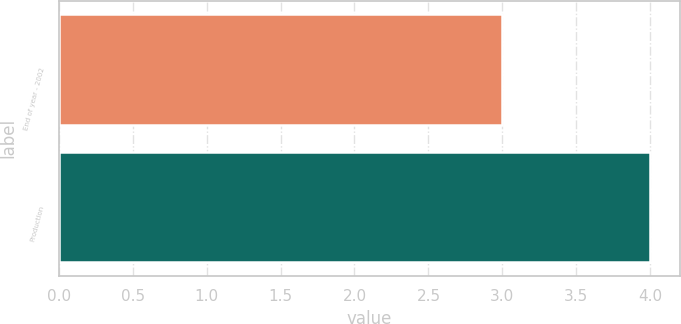Convert chart to OTSL. <chart><loc_0><loc_0><loc_500><loc_500><bar_chart><fcel>End of year - 2002<fcel>Production<nl><fcel>3<fcel>4<nl></chart> 